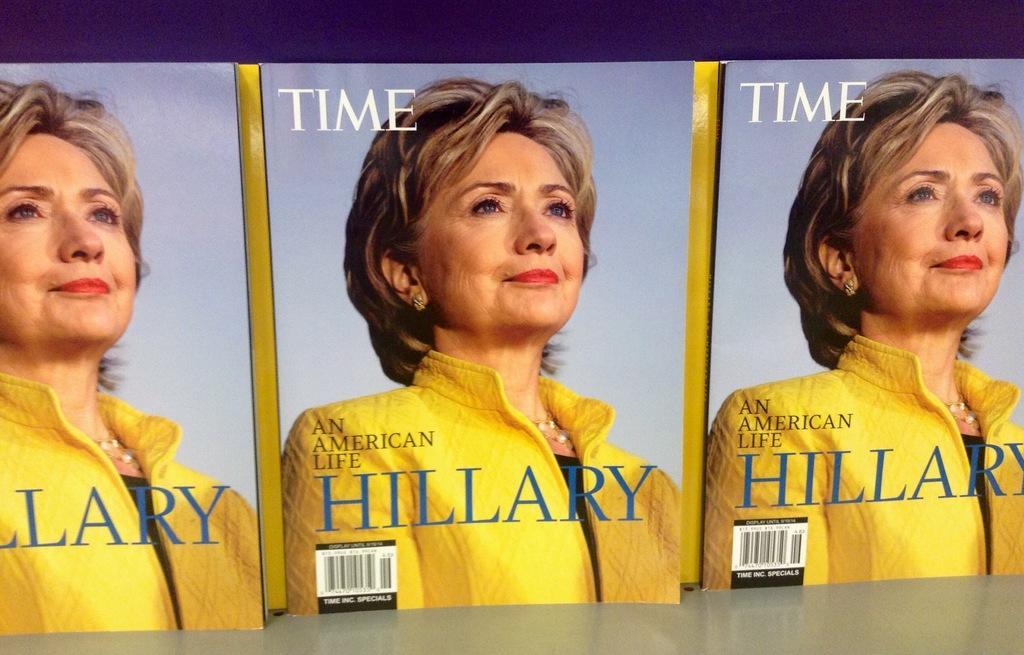How would you summarize this image in a sentence or two? In this image there are three magazine ,on that there is a picture of a women and there is some text. 